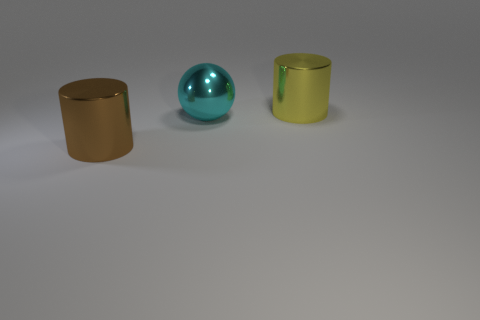Add 3 yellow metallic cylinders. How many objects exist? 6 Subtract all cylinders. How many objects are left? 1 Subtract all large cyan shiny objects. Subtract all large yellow shiny things. How many objects are left? 1 Add 3 large cylinders. How many large cylinders are left? 5 Add 3 cyan shiny objects. How many cyan shiny objects exist? 4 Subtract 0 green cylinders. How many objects are left? 3 